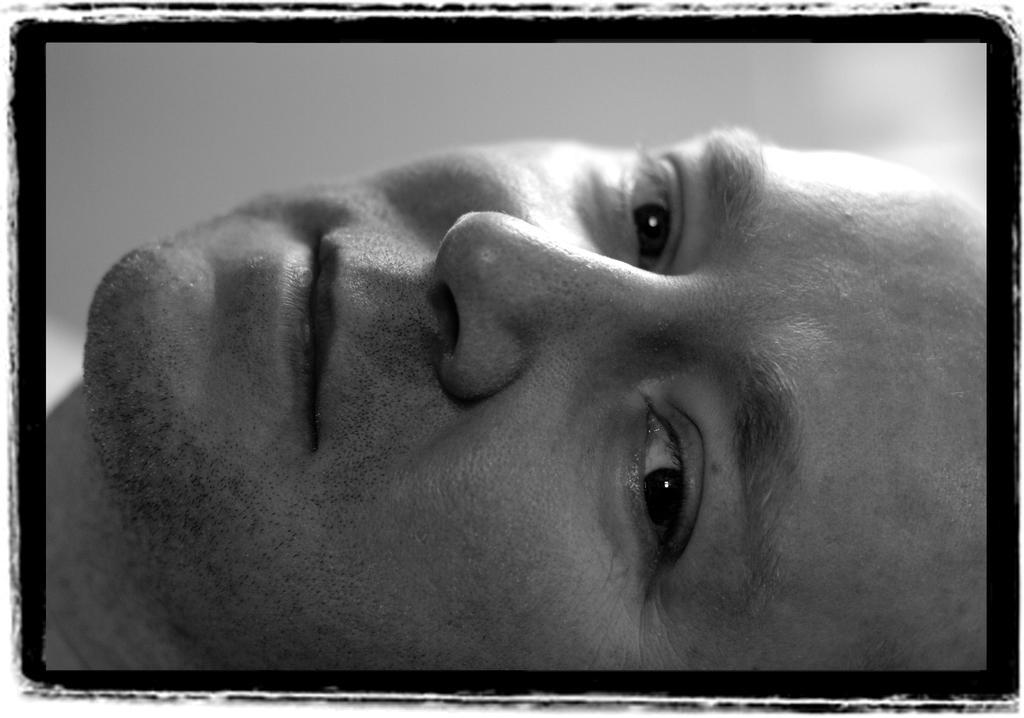Describe this image in one or two sentences. In this picture we can see a man´s face, there is a blurry background, we can see black color border. 